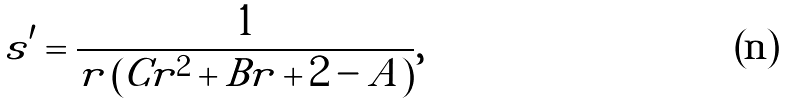<formula> <loc_0><loc_0><loc_500><loc_500>s ^ { \prime } = \frac { 1 } { r \left ( C r ^ { 2 } + B r + 2 - A \right ) } ,</formula> 